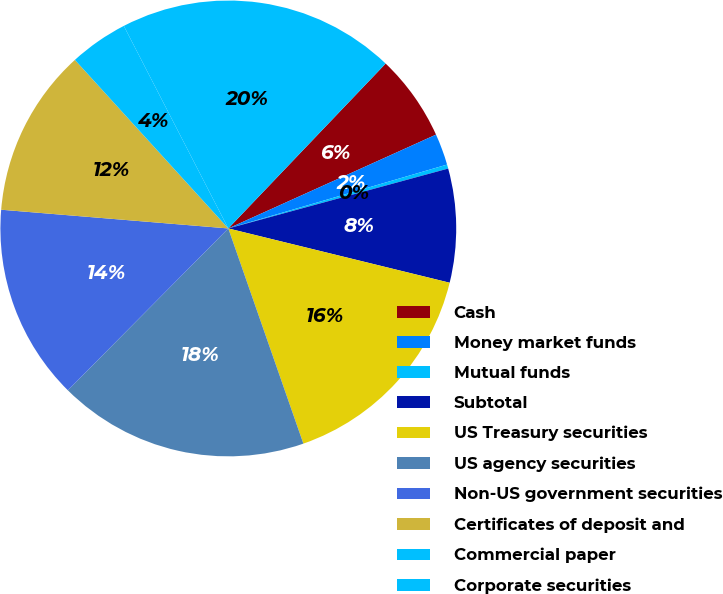<chart> <loc_0><loc_0><loc_500><loc_500><pie_chart><fcel>Cash<fcel>Money market funds<fcel>Mutual funds<fcel>Subtotal<fcel>US Treasury securities<fcel>US agency securities<fcel>Non-US government securities<fcel>Certificates of deposit and<fcel>Commercial paper<fcel>Corporate securities<nl><fcel>6.12%<fcel>2.23%<fcel>0.29%<fcel>8.06%<fcel>15.83%<fcel>17.77%<fcel>13.88%<fcel>11.94%<fcel>4.17%<fcel>19.71%<nl></chart> 